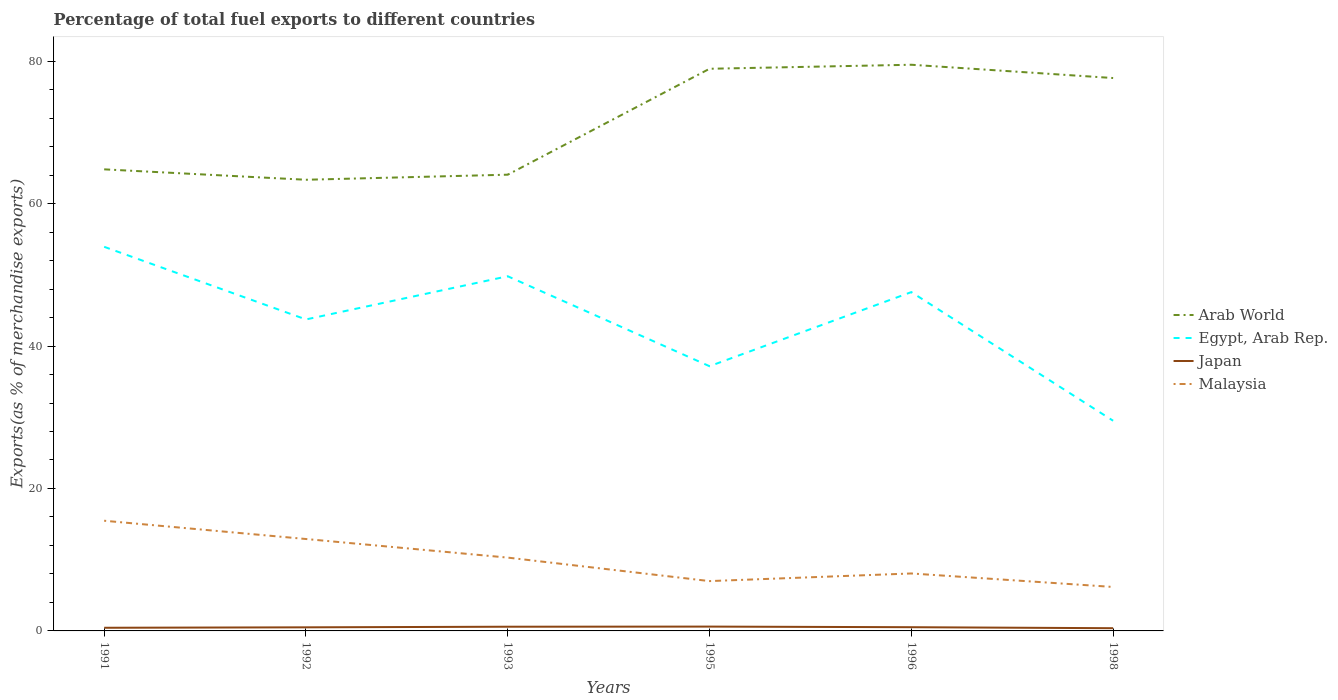How many different coloured lines are there?
Provide a short and direct response. 4. Does the line corresponding to Arab World intersect with the line corresponding to Egypt, Arab Rep.?
Make the answer very short. No. Across all years, what is the maximum percentage of exports to different countries in Japan?
Make the answer very short. 0.38. In which year was the percentage of exports to different countries in Malaysia maximum?
Your answer should be compact. 1998. What is the total percentage of exports to different countries in Arab World in the graph?
Offer a very short reply. -13.57. What is the difference between the highest and the second highest percentage of exports to different countries in Japan?
Give a very brief answer. 0.23. What is the difference between the highest and the lowest percentage of exports to different countries in Egypt, Arab Rep.?
Make the answer very short. 4. How many years are there in the graph?
Keep it short and to the point. 6. Where does the legend appear in the graph?
Provide a succinct answer. Center right. What is the title of the graph?
Offer a very short reply. Percentage of total fuel exports to different countries. Does "Sao Tome and Principe" appear as one of the legend labels in the graph?
Keep it short and to the point. No. What is the label or title of the Y-axis?
Your answer should be very brief. Exports(as % of merchandise exports). What is the Exports(as % of merchandise exports) of Arab World in 1991?
Ensure brevity in your answer.  64.81. What is the Exports(as % of merchandise exports) in Egypt, Arab Rep. in 1991?
Offer a terse response. 53.93. What is the Exports(as % of merchandise exports) in Japan in 1991?
Provide a short and direct response. 0.44. What is the Exports(as % of merchandise exports) in Malaysia in 1991?
Your answer should be very brief. 15.47. What is the Exports(as % of merchandise exports) of Arab World in 1992?
Offer a very short reply. 63.35. What is the Exports(as % of merchandise exports) in Egypt, Arab Rep. in 1992?
Ensure brevity in your answer.  43.73. What is the Exports(as % of merchandise exports) of Japan in 1992?
Your answer should be compact. 0.5. What is the Exports(as % of merchandise exports) of Malaysia in 1992?
Provide a short and direct response. 12.91. What is the Exports(as % of merchandise exports) in Arab World in 1993?
Your response must be concise. 64.06. What is the Exports(as % of merchandise exports) of Egypt, Arab Rep. in 1993?
Your response must be concise. 49.8. What is the Exports(as % of merchandise exports) in Japan in 1993?
Offer a terse response. 0.59. What is the Exports(as % of merchandise exports) of Malaysia in 1993?
Ensure brevity in your answer.  10.29. What is the Exports(as % of merchandise exports) of Arab World in 1995?
Provide a short and direct response. 78.93. What is the Exports(as % of merchandise exports) in Egypt, Arab Rep. in 1995?
Keep it short and to the point. 37.17. What is the Exports(as % of merchandise exports) of Japan in 1995?
Your answer should be very brief. 0.61. What is the Exports(as % of merchandise exports) of Malaysia in 1995?
Give a very brief answer. 7. What is the Exports(as % of merchandise exports) of Arab World in 1996?
Make the answer very short. 79.49. What is the Exports(as % of merchandise exports) in Egypt, Arab Rep. in 1996?
Make the answer very short. 47.57. What is the Exports(as % of merchandise exports) of Japan in 1996?
Ensure brevity in your answer.  0.52. What is the Exports(as % of merchandise exports) of Malaysia in 1996?
Offer a terse response. 8.07. What is the Exports(as % of merchandise exports) in Arab World in 1998?
Give a very brief answer. 77.63. What is the Exports(as % of merchandise exports) of Egypt, Arab Rep. in 1998?
Make the answer very short. 29.51. What is the Exports(as % of merchandise exports) in Japan in 1998?
Offer a very short reply. 0.38. What is the Exports(as % of merchandise exports) of Malaysia in 1998?
Provide a succinct answer. 6.17. Across all years, what is the maximum Exports(as % of merchandise exports) in Arab World?
Offer a very short reply. 79.49. Across all years, what is the maximum Exports(as % of merchandise exports) of Egypt, Arab Rep.?
Ensure brevity in your answer.  53.93. Across all years, what is the maximum Exports(as % of merchandise exports) in Japan?
Ensure brevity in your answer.  0.61. Across all years, what is the maximum Exports(as % of merchandise exports) of Malaysia?
Your answer should be compact. 15.47. Across all years, what is the minimum Exports(as % of merchandise exports) of Arab World?
Your response must be concise. 63.35. Across all years, what is the minimum Exports(as % of merchandise exports) in Egypt, Arab Rep.?
Your answer should be compact. 29.51. Across all years, what is the minimum Exports(as % of merchandise exports) of Japan?
Provide a succinct answer. 0.38. Across all years, what is the minimum Exports(as % of merchandise exports) of Malaysia?
Offer a terse response. 6.17. What is the total Exports(as % of merchandise exports) of Arab World in the graph?
Your response must be concise. 428.27. What is the total Exports(as % of merchandise exports) in Egypt, Arab Rep. in the graph?
Give a very brief answer. 261.72. What is the total Exports(as % of merchandise exports) of Japan in the graph?
Keep it short and to the point. 3.05. What is the total Exports(as % of merchandise exports) in Malaysia in the graph?
Ensure brevity in your answer.  59.91. What is the difference between the Exports(as % of merchandise exports) of Arab World in 1991 and that in 1992?
Your answer should be very brief. 1.46. What is the difference between the Exports(as % of merchandise exports) in Egypt, Arab Rep. in 1991 and that in 1992?
Make the answer very short. 10.2. What is the difference between the Exports(as % of merchandise exports) of Japan in 1991 and that in 1992?
Offer a very short reply. -0.06. What is the difference between the Exports(as % of merchandise exports) in Malaysia in 1991 and that in 1992?
Your response must be concise. 2.57. What is the difference between the Exports(as % of merchandise exports) of Arab World in 1991 and that in 1993?
Your response must be concise. 0.75. What is the difference between the Exports(as % of merchandise exports) in Egypt, Arab Rep. in 1991 and that in 1993?
Your response must be concise. 4.14. What is the difference between the Exports(as % of merchandise exports) in Japan in 1991 and that in 1993?
Your answer should be compact. -0.15. What is the difference between the Exports(as % of merchandise exports) in Malaysia in 1991 and that in 1993?
Ensure brevity in your answer.  5.18. What is the difference between the Exports(as % of merchandise exports) in Arab World in 1991 and that in 1995?
Make the answer very short. -14.12. What is the difference between the Exports(as % of merchandise exports) of Egypt, Arab Rep. in 1991 and that in 1995?
Keep it short and to the point. 16.77. What is the difference between the Exports(as % of merchandise exports) of Japan in 1991 and that in 1995?
Your response must be concise. -0.17. What is the difference between the Exports(as % of merchandise exports) in Malaysia in 1991 and that in 1995?
Make the answer very short. 8.47. What is the difference between the Exports(as % of merchandise exports) of Arab World in 1991 and that in 1996?
Provide a short and direct response. -14.69. What is the difference between the Exports(as % of merchandise exports) in Egypt, Arab Rep. in 1991 and that in 1996?
Provide a succinct answer. 6.36. What is the difference between the Exports(as % of merchandise exports) in Japan in 1991 and that in 1996?
Offer a terse response. -0.08. What is the difference between the Exports(as % of merchandise exports) in Malaysia in 1991 and that in 1996?
Provide a short and direct response. 7.4. What is the difference between the Exports(as % of merchandise exports) of Arab World in 1991 and that in 1998?
Make the answer very short. -12.82. What is the difference between the Exports(as % of merchandise exports) of Egypt, Arab Rep. in 1991 and that in 1998?
Provide a short and direct response. 24.42. What is the difference between the Exports(as % of merchandise exports) of Japan in 1991 and that in 1998?
Keep it short and to the point. 0.06. What is the difference between the Exports(as % of merchandise exports) of Malaysia in 1991 and that in 1998?
Give a very brief answer. 9.3. What is the difference between the Exports(as % of merchandise exports) of Arab World in 1992 and that in 1993?
Offer a very short reply. -0.71. What is the difference between the Exports(as % of merchandise exports) in Egypt, Arab Rep. in 1992 and that in 1993?
Keep it short and to the point. -6.06. What is the difference between the Exports(as % of merchandise exports) in Japan in 1992 and that in 1993?
Your answer should be very brief. -0.08. What is the difference between the Exports(as % of merchandise exports) of Malaysia in 1992 and that in 1993?
Offer a very short reply. 2.61. What is the difference between the Exports(as % of merchandise exports) of Arab World in 1992 and that in 1995?
Provide a succinct answer. -15.58. What is the difference between the Exports(as % of merchandise exports) of Egypt, Arab Rep. in 1992 and that in 1995?
Your response must be concise. 6.57. What is the difference between the Exports(as % of merchandise exports) in Japan in 1992 and that in 1995?
Your answer should be compact. -0.1. What is the difference between the Exports(as % of merchandise exports) of Malaysia in 1992 and that in 1995?
Your response must be concise. 5.91. What is the difference between the Exports(as % of merchandise exports) of Arab World in 1992 and that in 1996?
Give a very brief answer. -16.15. What is the difference between the Exports(as % of merchandise exports) in Egypt, Arab Rep. in 1992 and that in 1996?
Provide a short and direct response. -3.84. What is the difference between the Exports(as % of merchandise exports) in Japan in 1992 and that in 1996?
Offer a very short reply. -0.02. What is the difference between the Exports(as % of merchandise exports) in Malaysia in 1992 and that in 1996?
Give a very brief answer. 4.84. What is the difference between the Exports(as % of merchandise exports) of Arab World in 1992 and that in 1998?
Your response must be concise. -14.28. What is the difference between the Exports(as % of merchandise exports) of Egypt, Arab Rep. in 1992 and that in 1998?
Provide a short and direct response. 14.22. What is the difference between the Exports(as % of merchandise exports) in Japan in 1992 and that in 1998?
Ensure brevity in your answer.  0.12. What is the difference between the Exports(as % of merchandise exports) of Malaysia in 1992 and that in 1998?
Your response must be concise. 6.73. What is the difference between the Exports(as % of merchandise exports) of Arab World in 1993 and that in 1995?
Provide a short and direct response. -14.87. What is the difference between the Exports(as % of merchandise exports) of Egypt, Arab Rep. in 1993 and that in 1995?
Ensure brevity in your answer.  12.63. What is the difference between the Exports(as % of merchandise exports) of Japan in 1993 and that in 1995?
Give a very brief answer. -0.02. What is the difference between the Exports(as % of merchandise exports) of Malaysia in 1993 and that in 1995?
Ensure brevity in your answer.  3.3. What is the difference between the Exports(as % of merchandise exports) of Arab World in 1993 and that in 1996?
Ensure brevity in your answer.  -15.44. What is the difference between the Exports(as % of merchandise exports) in Egypt, Arab Rep. in 1993 and that in 1996?
Make the answer very short. 2.23. What is the difference between the Exports(as % of merchandise exports) in Japan in 1993 and that in 1996?
Your answer should be compact. 0.07. What is the difference between the Exports(as % of merchandise exports) of Malaysia in 1993 and that in 1996?
Ensure brevity in your answer.  2.23. What is the difference between the Exports(as % of merchandise exports) in Arab World in 1993 and that in 1998?
Provide a succinct answer. -13.57. What is the difference between the Exports(as % of merchandise exports) of Egypt, Arab Rep. in 1993 and that in 1998?
Your answer should be compact. 20.29. What is the difference between the Exports(as % of merchandise exports) of Japan in 1993 and that in 1998?
Give a very brief answer. 0.21. What is the difference between the Exports(as % of merchandise exports) in Malaysia in 1993 and that in 1998?
Your response must be concise. 4.12. What is the difference between the Exports(as % of merchandise exports) of Arab World in 1995 and that in 1996?
Your answer should be very brief. -0.56. What is the difference between the Exports(as % of merchandise exports) of Egypt, Arab Rep. in 1995 and that in 1996?
Offer a terse response. -10.4. What is the difference between the Exports(as % of merchandise exports) of Japan in 1995 and that in 1996?
Ensure brevity in your answer.  0.09. What is the difference between the Exports(as % of merchandise exports) in Malaysia in 1995 and that in 1996?
Make the answer very short. -1.07. What is the difference between the Exports(as % of merchandise exports) in Arab World in 1995 and that in 1998?
Your answer should be compact. 1.3. What is the difference between the Exports(as % of merchandise exports) in Egypt, Arab Rep. in 1995 and that in 1998?
Your answer should be very brief. 7.66. What is the difference between the Exports(as % of merchandise exports) in Japan in 1995 and that in 1998?
Provide a short and direct response. 0.23. What is the difference between the Exports(as % of merchandise exports) of Malaysia in 1995 and that in 1998?
Keep it short and to the point. 0.82. What is the difference between the Exports(as % of merchandise exports) of Arab World in 1996 and that in 1998?
Make the answer very short. 1.87. What is the difference between the Exports(as % of merchandise exports) in Egypt, Arab Rep. in 1996 and that in 1998?
Your response must be concise. 18.06. What is the difference between the Exports(as % of merchandise exports) of Japan in 1996 and that in 1998?
Keep it short and to the point. 0.14. What is the difference between the Exports(as % of merchandise exports) of Malaysia in 1996 and that in 1998?
Offer a very short reply. 1.9. What is the difference between the Exports(as % of merchandise exports) in Arab World in 1991 and the Exports(as % of merchandise exports) in Egypt, Arab Rep. in 1992?
Provide a succinct answer. 21.07. What is the difference between the Exports(as % of merchandise exports) in Arab World in 1991 and the Exports(as % of merchandise exports) in Japan in 1992?
Offer a terse response. 64.3. What is the difference between the Exports(as % of merchandise exports) in Arab World in 1991 and the Exports(as % of merchandise exports) in Malaysia in 1992?
Provide a short and direct response. 51.9. What is the difference between the Exports(as % of merchandise exports) of Egypt, Arab Rep. in 1991 and the Exports(as % of merchandise exports) of Japan in 1992?
Ensure brevity in your answer.  53.43. What is the difference between the Exports(as % of merchandise exports) of Egypt, Arab Rep. in 1991 and the Exports(as % of merchandise exports) of Malaysia in 1992?
Make the answer very short. 41.03. What is the difference between the Exports(as % of merchandise exports) in Japan in 1991 and the Exports(as % of merchandise exports) in Malaysia in 1992?
Give a very brief answer. -12.46. What is the difference between the Exports(as % of merchandise exports) of Arab World in 1991 and the Exports(as % of merchandise exports) of Egypt, Arab Rep. in 1993?
Your response must be concise. 15.01. What is the difference between the Exports(as % of merchandise exports) of Arab World in 1991 and the Exports(as % of merchandise exports) of Japan in 1993?
Give a very brief answer. 64.22. What is the difference between the Exports(as % of merchandise exports) in Arab World in 1991 and the Exports(as % of merchandise exports) in Malaysia in 1993?
Keep it short and to the point. 54.51. What is the difference between the Exports(as % of merchandise exports) in Egypt, Arab Rep. in 1991 and the Exports(as % of merchandise exports) in Japan in 1993?
Provide a short and direct response. 53.34. What is the difference between the Exports(as % of merchandise exports) in Egypt, Arab Rep. in 1991 and the Exports(as % of merchandise exports) in Malaysia in 1993?
Give a very brief answer. 43.64. What is the difference between the Exports(as % of merchandise exports) in Japan in 1991 and the Exports(as % of merchandise exports) in Malaysia in 1993?
Make the answer very short. -9.85. What is the difference between the Exports(as % of merchandise exports) in Arab World in 1991 and the Exports(as % of merchandise exports) in Egypt, Arab Rep. in 1995?
Your answer should be compact. 27.64. What is the difference between the Exports(as % of merchandise exports) in Arab World in 1991 and the Exports(as % of merchandise exports) in Japan in 1995?
Offer a very short reply. 64.2. What is the difference between the Exports(as % of merchandise exports) in Arab World in 1991 and the Exports(as % of merchandise exports) in Malaysia in 1995?
Offer a very short reply. 57.81. What is the difference between the Exports(as % of merchandise exports) in Egypt, Arab Rep. in 1991 and the Exports(as % of merchandise exports) in Japan in 1995?
Provide a short and direct response. 53.32. What is the difference between the Exports(as % of merchandise exports) of Egypt, Arab Rep. in 1991 and the Exports(as % of merchandise exports) of Malaysia in 1995?
Ensure brevity in your answer.  46.94. What is the difference between the Exports(as % of merchandise exports) of Japan in 1991 and the Exports(as % of merchandise exports) of Malaysia in 1995?
Make the answer very short. -6.55. What is the difference between the Exports(as % of merchandise exports) of Arab World in 1991 and the Exports(as % of merchandise exports) of Egypt, Arab Rep. in 1996?
Keep it short and to the point. 17.24. What is the difference between the Exports(as % of merchandise exports) in Arab World in 1991 and the Exports(as % of merchandise exports) in Japan in 1996?
Make the answer very short. 64.29. What is the difference between the Exports(as % of merchandise exports) of Arab World in 1991 and the Exports(as % of merchandise exports) of Malaysia in 1996?
Provide a succinct answer. 56.74. What is the difference between the Exports(as % of merchandise exports) of Egypt, Arab Rep. in 1991 and the Exports(as % of merchandise exports) of Japan in 1996?
Your response must be concise. 53.41. What is the difference between the Exports(as % of merchandise exports) of Egypt, Arab Rep. in 1991 and the Exports(as % of merchandise exports) of Malaysia in 1996?
Your answer should be very brief. 45.87. What is the difference between the Exports(as % of merchandise exports) in Japan in 1991 and the Exports(as % of merchandise exports) in Malaysia in 1996?
Provide a short and direct response. -7.62. What is the difference between the Exports(as % of merchandise exports) in Arab World in 1991 and the Exports(as % of merchandise exports) in Egypt, Arab Rep. in 1998?
Provide a succinct answer. 35.3. What is the difference between the Exports(as % of merchandise exports) in Arab World in 1991 and the Exports(as % of merchandise exports) in Japan in 1998?
Give a very brief answer. 64.43. What is the difference between the Exports(as % of merchandise exports) in Arab World in 1991 and the Exports(as % of merchandise exports) in Malaysia in 1998?
Keep it short and to the point. 58.64. What is the difference between the Exports(as % of merchandise exports) of Egypt, Arab Rep. in 1991 and the Exports(as % of merchandise exports) of Japan in 1998?
Your answer should be compact. 53.55. What is the difference between the Exports(as % of merchandise exports) in Egypt, Arab Rep. in 1991 and the Exports(as % of merchandise exports) in Malaysia in 1998?
Your answer should be very brief. 47.76. What is the difference between the Exports(as % of merchandise exports) of Japan in 1991 and the Exports(as % of merchandise exports) of Malaysia in 1998?
Offer a very short reply. -5.73. What is the difference between the Exports(as % of merchandise exports) of Arab World in 1992 and the Exports(as % of merchandise exports) of Egypt, Arab Rep. in 1993?
Keep it short and to the point. 13.55. What is the difference between the Exports(as % of merchandise exports) of Arab World in 1992 and the Exports(as % of merchandise exports) of Japan in 1993?
Make the answer very short. 62.76. What is the difference between the Exports(as % of merchandise exports) of Arab World in 1992 and the Exports(as % of merchandise exports) of Malaysia in 1993?
Provide a short and direct response. 53.05. What is the difference between the Exports(as % of merchandise exports) in Egypt, Arab Rep. in 1992 and the Exports(as % of merchandise exports) in Japan in 1993?
Make the answer very short. 43.15. What is the difference between the Exports(as % of merchandise exports) of Egypt, Arab Rep. in 1992 and the Exports(as % of merchandise exports) of Malaysia in 1993?
Keep it short and to the point. 33.44. What is the difference between the Exports(as % of merchandise exports) in Japan in 1992 and the Exports(as % of merchandise exports) in Malaysia in 1993?
Provide a succinct answer. -9.79. What is the difference between the Exports(as % of merchandise exports) of Arab World in 1992 and the Exports(as % of merchandise exports) of Egypt, Arab Rep. in 1995?
Provide a succinct answer. 26.18. What is the difference between the Exports(as % of merchandise exports) of Arab World in 1992 and the Exports(as % of merchandise exports) of Japan in 1995?
Offer a terse response. 62.74. What is the difference between the Exports(as % of merchandise exports) in Arab World in 1992 and the Exports(as % of merchandise exports) in Malaysia in 1995?
Make the answer very short. 56.35. What is the difference between the Exports(as % of merchandise exports) in Egypt, Arab Rep. in 1992 and the Exports(as % of merchandise exports) in Japan in 1995?
Offer a terse response. 43.13. What is the difference between the Exports(as % of merchandise exports) in Egypt, Arab Rep. in 1992 and the Exports(as % of merchandise exports) in Malaysia in 1995?
Your answer should be very brief. 36.74. What is the difference between the Exports(as % of merchandise exports) in Japan in 1992 and the Exports(as % of merchandise exports) in Malaysia in 1995?
Keep it short and to the point. -6.49. What is the difference between the Exports(as % of merchandise exports) in Arab World in 1992 and the Exports(as % of merchandise exports) in Egypt, Arab Rep. in 1996?
Provide a short and direct response. 15.77. What is the difference between the Exports(as % of merchandise exports) of Arab World in 1992 and the Exports(as % of merchandise exports) of Japan in 1996?
Your response must be concise. 62.82. What is the difference between the Exports(as % of merchandise exports) in Arab World in 1992 and the Exports(as % of merchandise exports) in Malaysia in 1996?
Your answer should be compact. 55.28. What is the difference between the Exports(as % of merchandise exports) of Egypt, Arab Rep. in 1992 and the Exports(as % of merchandise exports) of Japan in 1996?
Provide a succinct answer. 43.21. What is the difference between the Exports(as % of merchandise exports) of Egypt, Arab Rep. in 1992 and the Exports(as % of merchandise exports) of Malaysia in 1996?
Provide a short and direct response. 35.67. What is the difference between the Exports(as % of merchandise exports) in Japan in 1992 and the Exports(as % of merchandise exports) in Malaysia in 1996?
Offer a very short reply. -7.56. What is the difference between the Exports(as % of merchandise exports) in Arab World in 1992 and the Exports(as % of merchandise exports) in Egypt, Arab Rep. in 1998?
Offer a terse response. 33.84. What is the difference between the Exports(as % of merchandise exports) in Arab World in 1992 and the Exports(as % of merchandise exports) in Japan in 1998?
Give a very brief answer. 62.97. What is the difference between the Exports(as % of merchandise exports) of Arab World in 1992 and the Exports(as % of merchandise exports) of Malaysia in 1998?
Your response must be concise. 57.17. What is the difference between the Exports(as % of merchandise exports) in Egypt, Arab Rep. in 1992 and the Exports(as % of merchandise exports) in Japan in 1998?
Your answer should be very brief. 43.35. What is the difference between the Exports(as % of merchandise exports) in Egypt, Arab Rep. in 1992 and the Exports(as % of merchandise exports) in Malaysia in 1998?
Offer a very short reply. 37.56. What is the difference between the Exports(as % of merchandise exports) of Japan in 1992 and the Exports(as % of merchandise exports) of Malaysia in 1998?
Your answer should be very brief. -5.67. What is the difference between the Exports(as % of merchandise exports) in Arab World in 1993 and the Exports(as % of merchandise exports) in Egypt, Arab Rep. in 1995?
Provide a short and direct response. 26.89. What is the difference between the Exports(as % of merchandise exports) in Arab World in 1993 and the Exports(as % of merchandise exports) in Japan in 1995?
Make the answer very short. 63.45. What is the difference between the Exports(as % of merchandise exports) of Arab World in 1993 and the Exports(as % of merchandise exports) of Malaysia in 1995?
Give a very brief answer. 57.06. What is the difference between the Exports(as % of merchandise exports) of Egypt, Arab Rep. in 1993 and the Exports(as % of merchandise exports) of Japan in 1995?
Your response must be concise. 49.19. What is the difference between the Exports(as % of merchandise exports) in Egypt, Arab Rep. in 1993 and the Exports(as % of merchandise exports) in Malaysia in 1995?
Give a very brief answer. 42.8. What is the difference between the Exports(as % of merchandise exports) of Japan in 1993 and the Exports(as % of merchandise exports) of Malaysia in 1995?
Ensure brevity in your answer.  -6.41. What is the difference between the Exports(as % of merchandise exports) of Arab World in 1993 and the Exports(as % of merchandise exports) of Egypt, Arab Rep. in 1996?
Your answer should be very brief. 16.49. What is the difference between the Exports(as % of merchandise exports) in Arab World in 1993 and the Exports(as % of merchandise exports) in Japan in 1996?
Ensure brevity in your answer.  63.54. What is the difference between the Exports(as % of merchandise exports) of Arab World in 1993 and the Exports(as % of merchandise exports) of Malaysia in 1996?
Keep it short and to the point. 55.99. What is the difference between the Exports(as % of merchandise exports) in Egypt, Arab Rep. in 1993 and the Exports(as % of merchandise exports) in Japan in 1996?
Ensure brevity in your answer.  49.28. What is the difference between the Exports(as % of merchandise exports) of Egypt, Arab Rep. in 1993 and the Exports(as % of merchandise exports) of Malaysia in 1996?
Give a very brief answer. 41.73. What is the difference between the Exports(as % of merchandise exports) in Japan in 1993 and the Exports(as % of merchandise exports) in Malaysia in 1996?
Offer a terse response. -7.48. What is the difference between the Exports(as % of merchandise exports) of Arab World in 1993 and the Exports(as % of merchandise exports) of Egypt, Arab Rep. in 1998?
Give a very brief answer. 34.55. What is the difference between the Exports(as % of merchandise exports) of Arab World in 1993 and the Exports(as % of merchandise exports) of Japan in 1998?
Give a very brief answer. 63.68. What is the difference between the Exports(as % of merchandise exports) of Arab World in 1993 and the Exports(as % of merchandise exports) of Malaysia in 1998?
Offer a terse response. 57.89. What is the difference between the Exports(as % of merchandise exports) in Egypt, Arab Rep. in 1993 and the Exports(as % of merchandise exports) in Japan in 1998?
Provide a short and direct response. 49.42. What is the difference between the Exports(as % of merchandise exports) in Egypt, Arab Rep. in 1993 and the Exports(as % of merchandise exports) in Malaysia in 1998?
Ensure brevity in your answer.  43.63. What is the difference between the Exports(as % of merchandise exports) of Japan in 1993 and the Exports(as % of merchandise exports) of Malaysia in 1998?
Keep it short and to the point. -5.58. What is the difference between the Exports(as % of merchandise exports) in Arab World in 1995 and the Exports(as % of merchandise exports) in Egypt, Arab Rep. in 1996?
Provide a succinct answer. 31.36. What is the difference between the Exports(as % of merchandise exports) of Arab World in 1995 and the Exports(as % of merchandise exports) of Japan in 1996?
Keep it short and to the point. 78.41. What is the difference between the Exports(as % of merchandise exports) in Arab World in 1995 and the Exports(as % of merchandise exports) in Malaysia in 1996?
Ensure brevity in your answer.  70.86. What is the difference between the Exports(as % of merchandise exports) in Egypt, Arab Rep. in 1995 and the Exports(as % of merchandise exports) in Japan in 1996?
Your response must be concise. 36.65. What is the difference between the Exports(as % of merchandise exports) in Egypt, Arab Rep. in 1995 and the Exports(as % of merchandise exports) in Malaysia in 1996?
Give a very brief answer. 29.1. What is the difference between the Exports(as % of merchandise exports) of Japan in 1995 and the Exports(as % of merchandise exports) of Malaysia in 1996?
Give a very brief answer. -7.46. What is the difference between the Exports(as % of merchandise exports) in Arab World in 1995 and the Exports(as % of merchandise exports) in Egypt, Arab Rep. in 1998?
Provide a short and direct response. 49.42. What is the difference between the Exports(as % of merchandise exports) in Arab World in 1995 and the Exports(as % of merchandise exports) in Japan in 1998?
Keep it short and to the point. 78.55. What is the difference between the Exports(as % of merchandise exports) in Arab World in 1995 and the Exports(as % of merchandise exports) in Malaysia in 1998?
Offer a very short reply. 72.76. What is the difference between the Exports(as % of merchandise exports) in Egypt, Arab Rep. in 1995 and the Exports(as % of merchandise exports) in Japan in 1998?
Keep it short and to the point. 36.79. What is the difference between the Exports(as % of merchandise exports) in Egypt, Arab Rep. in 1995 and the Exports(as % of merchandise exports) in Malaysia in 1998?
Provide a succinct answer. 31. What is the difference between the Exports(as % of merchandise exports) in Japan in 1995 and the Exports(as % of merchandise exports) in Malaysia in 1998?
Keep it short and to the point. -5.56. What is the difference between the Exports(as % of merchandise exports) of Arab World in 1996 and the Exports(as % of merchandise exports) of Egypt, Arab Rep. in 1998?
Make the answer very short. 49.98. What is the difference between the Exports(as % of merchandise exports) in Arab World in 1996 and the Exports(as % of merchandise exports) in Japan in 1998?
Your response must be concise. 79.11. What is the difference between the Exports(as % of merchandise exports) of Arab World in 1996 and the Exports(as % of merchandise exports) of Malaysia in 1998?
Your answer should be very brief. 73.32. What is the difference between the Exports(as % of merchandise exports) in Egypt, Arab Rep. in 1996 and the Exports(as % of merchandise exports) in Japan in 1998?
Keep it short and to the point. 47.19. What is the difference between the Exports(as % of merchandise exports) of Egypt, Arab Rep. in 1996 and the Exports(as % of merchandise exports) of Malaysia in 1998?
Provide a short and direct response. 41.4. What is the difference between the Exports(as % of merchandise exports) in Japan in 1996 and the Exports(as % of merchandise exports) in Malaysia in 1998?
Give a very brief answer. -5.65. What is the average Exports(as % of merchandise exports) of Arab World per year?
Your answer should be compact. 71.38. What is the average Exports(as % of merchandise exports) in Egypt, Arab Rep. per year?
Provide a succinct answer. 43.62. What is the average Exports(as % of merchandise exports) of Japan per year?
Keep it short and to the point. 0.51. What is the average Exports(as % of merchandise exports) of Malaysia per year?
Offer a very short reply. 9.98. In the year 1991, what is the difference between the Exports(as % of merchandise exports) in Arab World and Exports(as % of merchandise exports) in Egypt, Arab Rep.?
Your response must be concise. 10.88. In the year 1991, what is the difference between the Exports(as % of merchandise exports) in Arab World and Exports(as % of merchandise exports) in Japan?
Ensure brevity in your answer.  64.37. In the year 1991, what is the difference between the Exports(as % of merchandise exports) of Arab World and Exports(as % of merchandise exports) of Malaysia?
Offer a terse response. 49.34. In the year 1991, what is the difference between the Exports(as % of merchandise exports) in Egypt, Arab Rep. and Exports(as % of merchandise exports) in Japan?
Offer a very short reply. 53.49. In the year 1991, what is the difference between the Exports(as % of merchandise exports) of Egypt, Arab Rep. and Exports(as % of merchandise exports) of Malaysia?
Offer a terse response. 38.46. In the year 1991, what is the difference between the Exports(as % of merchandise exports) of Japan and Exports(as % of merchandise exports) of Malaysia?
Offer a very short reply. -15.03. In the year 1992, what is the difference between the Exports(as % of merchandise exports) of Arab World and Exports(as % of merchandise exports) of Egypt, Arab Rep.?
Make the answer very short. 19.61. In the year 1992, what is the difference between the Exports(as % of merchandise exports) of Arab World and Exports(as % of merchandise exports) of Japan?
Keep it short and to the point. 62.84. In the year 1992, what is the difference between the Exports(as % of merchandise exports) of Arab World and Exports(as % of merchandise exports) of Malaysia?
Your answer should be very brief. 50.44. In the year 1992, what is the difference between the Exports(as % of merchandise exports) of Egypt, Arab Rep. and Exports(as % of merchandise exports) of Japan?
Offer a very short reply. 43.23. In the year 1992, what is the difference between the Exports(as % of merchandise exports) of Egypt, Arab Rep. and Exports(as % of merchandise exports) of Malaysia?
Offer a terse response. 30.83. In the year 1992, what is the difference between the Exports(as % of merchandise exports) of Japan and Exports(as % of merchandise exports) of Malaysia?
Ensure brevity in your answer.  -12.4. In the year 1993, what is the difference between the Exports(as % of merchandise exports) of Arab World and Exports(as % of merchandise exports) of Egypt, Arab Rep.?
Your answer should be compact. 14.26. In the year 1993, what is the difference between the Exports(as % of merchandise exports) in Arab World and Exports(as % of merchandise exports) in Japan?
Your answer should be compact. 63.47. In the year 1993, what is the difference between the Exports(as % of merchandise exports) in Arab World and Exports(as % of merchandise exports) in Malaysia?
Make the answer very short. 53.76. In the year 1993, what is the difference between the Exports(as % of merchandise exports) of Egypt, Arab Rep. and Exports(as % of merchandise exports) of Japan?
Your answer should be very brief. 49.21. In the year 1993, what is the difference between the Exports(as % of merchandise exports) of Egypt, Arab Rep. and Exports(as % of merchandise exports) of Malaysia?
Ensure brevity in your answer.  39.5. In the year 1993, what is the difference between the Exports(as % of merchandise exports) in Japan and Exports(as % of merchandise exports) in Malaysia?
Give a very brief answer. -9.7. In the year 1995, what is the difference between the Exports(as % of merchandise exports) of Arab World and Exports(as % of merchandise exports) of Egypt, Arab Rep.?
Your answer should be compact. 41.76. In the year 1995, what is the difference between the Exports(as % of merchandise exports) in Arab World and Exports(as % of merchandise exports) in Japan?
Make the answer very short. 78.32. In the year 1995, what is the difference between the Exports(as % of merchandise exports) of Arab World and Exports(as % of merchandise exports) of Malaysia?
Give a very brief answer. 71.93. In the year 1995, what is the difference between the Exports(as % of merchandise exports) in Egypt, Arab Rep. and Exports(as % of merchandise exports) in Japan?
Provide a short and direct response. 36.56. In the year 1995, what is the difference between the Exports(as % of merchandise exports) in Egypt, Arab Rep. and Exports(as % of merchandise exports) in Malaysia?
Offer a very short reply. 30.17. In the year 1995, what is the difference between the Exports(as % of merchandise exports) in Japan and Exports(as % of merchandise exports) in Malaysia?
Your answer should be compact. -6.39. In the year 1996, what is the difference between the Exports(as % of merchandise exports) of Arab World and Exports(as % of merchandise exports) of Egypt, Arab Rep.?
Provide a succinct answer. 31.92. In the year 1996, what is the difference between the Exports(as % of merchandise exports) in Arab World and Exports(as % of merchandise exports) in Japan?
Your answer should be compact. 78.97. In the year 1996, what is the difference between the Exports(as % of merchandise exports) of Arab World and Exports(as % of merchandise exports) of Malaysia?
Your answer should be very brief. 71.43. In the year 1996, what is the difference between the Exports(as % of merchandise exports) of Egypt, Arab Rep. and Exports(as % of merchandise exports) of Japan?
Make the answer very short. 47.05. In the year 1996, what is the difference between the Exports(as % of merchandise exports) in Egypt, Arab Rep. and Exports(as % of merchandise exports) in Malaysia?
Your answer should be very brief. 39.5. In the year 1996, what is the difference between the Exports(as % of merchandise exports) of Japan and Exports(as % of merchandise exports) of Malaysia?
Your answer should be compact. -7.54. In the year 1998, what is the difference between the Exports(as % of merchandise exports) in Arab World and Exports(as % of merchandise exports) in Egypt, Arab Rep.?
Ensure brevity in your answer.  48.12. In the year 1998, what is the difference between the Exports(as % of merchandise exports) in Arab World and Exports(as % of merchandise exports) in Japan?
Provide a short and direct response. 77.25. In the year 1998, what is the difference between the Exports(as % of merchandise exports) of Arab World and Exports(as % of merchandise exports) of Malaysia?
Offer a terse response. 71.46. In the year 1998, what is the difference between the Exports(as % of merchandise exports) in Egypt, Arab Rep. and Exports(as % of merchandise exports) in Japan?
Ensure brevity in your answer.  29.13. In the year 1998, what is the difference between the Exports(as % of merchandise exports) of Egypt, Arab Rep. and Exports(as % of merchandise exports) of Malaysia?
Ensure brevity in your answer.  23.34. In the year 1998, what is the difference between the Exports(as % of merchandise exports) of Japan and Exports(as % of merchandise exports) of Malaysia?
Your answer should be very brief. -5.79. What is the ratio of the Exports(as % of merchandise exports) in Arab World in 1991 to that in 1992?
Provide a succinct answer. 1.02. What is the ratio of the Exports(as % of merchandise exports) in Egypt, Arab Rep. in 1991 to that in 1992?
Make the answer very short. 1.23. What is the ratio of the Exports(as % of merchandise exports) of Japan in 1991 to that in 1992?
Offer a very short reply. 0.88. What is the ratio of the Exports(as % of merchandise exports) in Malaysia in 1991 to that in 1992?
Provide a short and direct response. 1.2. What is the ratio of the Exports(as % of merchandise exports) of Arab World in 1991 to that in 1993?
Provide a succinct answer. 1.01. What is the ratio of the Exports(as % of merchandise exports) of Egypt, Arab Rep. in 1991 to that in 1993?
Give a very brief answer. 1.08. What is the ratio of the Exports(as % of merchandise exports) of Japan in 1991 to that in 1993?
Your answer should be compact. 0.75. What is the ratio of the Exports(as % of merchandise exports) of Malaysia in 1991 to that in 1993?
Provide a short and direct response. 1.5. What is the ratio of the Exports(as % of merchandise exports) of Arab World in 1991 to that in 1995?
Your answer should be compact. 0.82. What is the ratio of the Exports(as % of merchandise exports) of Egypt, Arab Rep. in 1991 to that in 1995?
Your response must be concise. 1.45. What is the ratio of the Exports(as % of merchandise exports) in Japan in 1991 to that in 1995?
Ensure brevity in your answer.  0.73. What is the ratio of the Exports(as % of merchandise exports) of Malaysia in 1991 to that in 1995?
Keep it short and to the point. 2.21. What is the ratio of the Exports(as % of merchandise exports) of Arab World in 1991 to that in 1996?
Offer a terse response. 0.82. What is the ratio of the Exports(as % of merchandise exports) of Egypt, Arab Rep. in 1991 to that in 1996?
Offer a very short reply. 1.13. What is the ratio of the Exports(as % of merchandise exports) of Japan in 1991 to that in 1996?
Your answer should be compact. 0.85. What is the ratio of the Exports(as % of merchandise exports) of Malaysia in 1991 to that in 1996?
Your answer should be very brief. 1.92. What is the ratio of the Exports(as % of merchandise exports) in Arab World in 1991 to that in 1998?
Your response must be concise. 0.83. What is the ratio of the Exports(as % of merchandise exports) in Egypt, Arab Rep. in 1991 to that in 1998?
Offer a very short reply. 1.83. What is the ratio of the Exports(as % of merchandise exports) of Japan in 1991 to that in 1998?
Your response must be concise. 1.16. What is the ratio of the Exports(as % of merchandise exports) in Malaysia in 1991 to that in 1998?
Keep it short and to the point. 2.51. What is the ratio of the Exports(as % of merchandise exports) in Arab World in 1992 to that in 1993?
Offer a terse response. 0.99. What is the ratio of the Exports(as % of merchandise exports) in Egypt, Arab Rep. in 1992 to that in 1993?
Make the answer very short. 0.88. What is the ratio of the Exports(as % of merchandise exports) in Japan in 1992 to that in 1993?
Your answer should be very brief. 0.86. What is the ratio of the Exports(as % of merchandise exports) of Malaysia in 1992 to that in 1993?
Provide a succinct answer. 1.25. What is the ratio of the Exports(as % of merchandise exports) of Arab World in 1992 to that in 1995?
Provide a succinct answer. 0.8. What is the ratio of the Exports(as % of merchandise exports) of Egypt, Arab Rep. in 1992 to that in 1995?
Keep it short and to the point. 1.18. What is the ratio of the Exports(as % of merchandise exports) of Japan in 1992 to that in 1995?
Make the answer very short. 0.83. What is the ratio of the Exports(as % of merchandise exports) in Malaysia in 1992 to that in 1995?
Your answer should be compact. 1.84. What is the ratio of the Exports(as % of merchandise exports) of Arab World in 1992 to that in 1996?
Give a very brief answer. 0.8. What is the ratio of the Exports(as % of merchandise exports) of Egypt, Arab Rep. in 1992 to that in 1996?
Offer a very short reply. 0.92. What is the ratio of the Exports(as % of merchandise exports) of Japan in 1992 to that in 1996?
Your response must be concise. 0.97. What is the ratio of the Exports(as % of merchandise exports) in Malaysia in 1992 to that in 1996?
Your answer should be very brief. 1.6. What is the ratio of the Exports(as % of merchandise exports) in Arab World in 1992 to that in 1998?
Provide a short and direct response. 0.82. What is the ratio of the Exports(as % of merchandise exports) of Egypt, Arab Rep. in 1992 to that in 1998?
Your response must be concise. 1.48. What is the ratio of the Exports(as % of merchandise exports) in Japan in 1992 to that in 1998?
Your response must be concise. 1.33. What is the ratio of the Exports(as % of merchandise exports) of Malaysia in 1992 to that in 1998?
Your answer should be compact. 2.09. What is the ratio of the Exports(as % of merchandise exports) of Arab World in 1993 to that in 1995?
Offer a very short reply. 0.81. What is the ratio of the Exports(as % of merchandise exports) of Egypt, Arab Rep. in 1993 to that in 1995?
Ensure brevity in your answer.  1.34. What is the ratio of the Exports(as % of merchandise exports) in Japan in 1993 to that in 1995?
Keep it short and to the point. 0.97. What is the ratio of the Exports(as % of merchandise exports) in Malaysia in 1993 to that in 1995?
Provide a short and direct response. 1.47. What is the ratio of the Exports(as % of merchandise exports) of Arab World in 1993 to that in 1996?
Your answer should be compact. 0.81. What is the ratio of the Exports(as % of merchandise exports) of Egypt, Arab Rep. in 1993 to that in 1996?
Provide a succinct answer. 1.05. What is the ratio of the Exports(as % of merchandise exports) in Japan in 1993 to that in 1996?
Your response must be concise. 1.13. What is the ratio of the Exports(as % of merchandise exports) of Malaysia in 1993 to that in 1996?
Provide a short and direct response. 1.28. What is the ratio of the Exports(as % of merchandise exports) of Arab World in 1993 to that in 1998?
Provide a succinct answer. 0.83. What is the ratio of the Exports(as % of merchandise exports) of Egypt, Arab Rep. in 1993 to that in 1998?
Your response must be concise. 1.69. What is the ratio of the Exports(as % of merchandise exports) in Japan in 1993 to that in 1998?
Offer a terse response. 1.55. What is the ratio of the Exports(as % of merchandise exports) of Malaysia in 1993 to that in 1998?
Your answer should be compact. 1.67. What is the ratio of the Exports(as % of merchandise exports) of Arab World in 1995 to that in 1996?
Make the answer very short. 0.99. What is the ratio of the Exports(as % of merchandise exports) of Egypt, Arab Rep. in 1995 to that in 1996?
Provide a short and direct response. 0.78. What is the ratio of the Exports(as % of merchandise exports) of Japan in 1995 to that in 1996?
Offer a terse response. 1.16. What is the ratio of the Exports(as % of merchandise exports) of Malaysia in 1995 to that in 1996?
Make the answer very short. 0.87. What is the ratio of the Exports(as % of merchandise exports) in Arab World in 1995 to that in 1998?
Provide a short and direct response. 1.02. What is the ratio of the Exports(as % of merchandise exports) of Egypt, Arab Rep. in 1995 to that in 1998?
Give a very brief answer. 1.26. What is the ratio of the Exports(as % of merchandise exports) of Japan in 1995 to that in 1998?
Keep it short and to the point. 1.6. What is the ratio of the Exports(as % of merchandise exports) in Malaysia in 1995 to that in 1998?
Offer a terse response. 1.13. What is the ratio of the Exports(as % of merchandise exports) in Egypt, Arab Rep. in 1996 to that in 1998?
Offer a very short reply. 1.61. What is the ratio of the Exports(as % of merchandise exports) of Japan in 1996 to that in 1998?
Keep it short and to the point. 1.37. What is the ratio of the Exports(as % of merchandise exports) in Malaysia in 1996 to that in 1998?
Your response must be concise. 1.31. What is the difference between the highest and the second highest Exports(as % of merchandise exports) in Arab World?
Offer a terse response. 0.56. What is the difference between the highest and the second highest Exports(as % of merchandise exports) in Egypt, Arab Rep.?
Keep it short and to the point. 4.14. What is the difference between the highest and the second highest Exports(as % of merchandise exports) of Japan?
Ensure brevity in your answer.  0.02. What is the difference between the highest and the second highest Exports(as % of merchandise exports) in Malaysia?
Offer a very short reply. 2.57. What is the difference between the highest and the lowest Exports(as % of merchandise exports) in Arab World?
Provide a succinct answer. 16.15. What is the difference between the highest and the lowest Exports(as % of merchandise exports) of Egypt, Arab Rep.?
Provide a succinct answer. 24.42. What is the difference between the highest and the lowest Exports(as % of merchandise exports) in Japan?
Provide a succinct answer. 0.23. What is the difference between the highest and the lowest Exports(as % of merchandise exports) in Malaysia?
Offer a very short reply. 9.3. 